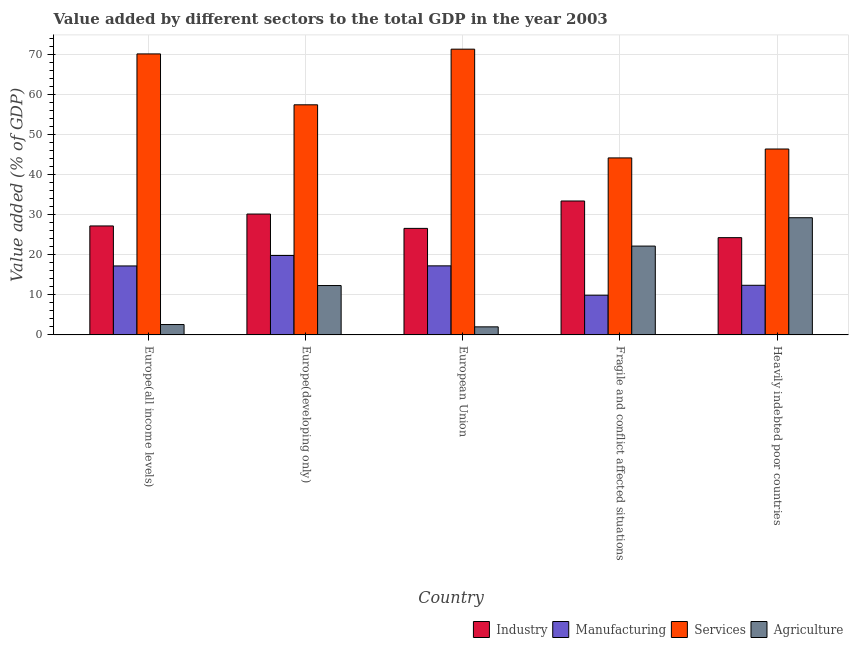How many groups of bars are there?
Make the answer very short. 5. Are the number of bars on each tick of the X-axis equal?
Offer a very short reply. Yes. What is the label of the 2nd group of bars from the left?
Keep it short and to the point. Europe(developing only). What is the value added by industrial sector in European Union?
Your answer should be very brief. 26.61. Across all countries, what is the maximum value added by manufacturing sector?
Your response must be concise. 19.84. Across all countries, what is the minimum value added by manufacturing sector?
Ensure brevity in your answer.  9.92. In which country was the value added by industrial sector maximum?
Your answer should be very brief. Fragile and conflict affected situations. What is the total value added by agricultural sector in the graph?
Your answer should be very brief. 68.4. What is the difference between the value added by agricultural sector in Europe(developing only) and that in Fragile and conflict affected situations?
Ensure brevity in your answer.  -9.85. What is the difference between the value added by agricultural sector in European Union and the value added by industrial sector in Fragile and conflict affected situations?
Provide a succinct answer. -31.44. What is the average value added by industrial sector per country?
Keep it short and to the point. 28.35. What is the difference between the value added by manufacturing sector and value added by services sector in Heavily indebted poor countries?
Offer a very short reply. -34.04. In how many countries, is the value added by agricultural sector greater than 6 %?
Offer a very short reply. 3. What is the ratio of the value added by industrial sector in European Union to that in Fragile and conflict affected situations?
Provide a succinct answer. 0.8. Is the value added by manufacturing sector in European Union less than that in Heavily indebted poor countries?
Offer a very short reply. No. What is the difference between the highest and the second highest value added by services sector?
Your response must be concise. 1.18. What is the difference between the highest and the lowest value added by agricultural sector?
Your answer should be very brief. 27.26. In how many countries, is the value added by industrial sector greater than the average value added by industrial sector taken over all countries?
Your response must be concise. 2. Is it the case that in every country, the sum of the value added by manufacturing sector and value added by services sector is greater than the sum of value added by agricultural sector and value added by industrial sector?
Your answer should be very brief. No. What does the 1st bar from the left in Heavily indebted poor countries represents?
Your answer should be very brief. Industry. What does the 2nd bar from the right in Heavily indebted poor countries represents?
Offer a terse response. Services. What is the difference between two consecutive major ticks on the Y-axis?
Provide a short and direct response. 10. Are the values on the major ticks of Y-axis written in scientific E-notation?
Make the answer very short. No. Does the graph contain any zero values?
Keep it short and to the point. No. Does the graph contain grids?
Ensure brevity in your answer.  Yes. How are the legend labels stacked?
Keep it short and to the point. Horizontal. What is the title of the graph?
Your response must be concise. Value added by different sectors to the total GDP in the year 2003. Does "Regional development banks" appear as one of the legend labels in the graph?
Provide a succinct answer. No. What is the label or title of the Y-axis?
Keep it short and to the point. Value added (% of GDP). What is the Value added (% of GDP) in Industry in Europe(all income levels)?
Offer a very short reply. 27.22. What is the Value added (% of GDP) in Manufacturing in Europe(all income levels)?
Your answer should be compact. 17.23. What is the Value added (% of GDP) of Services in Europe(all income levels)?
Offer a very short reply. 70.19. What is the Value added (% of GDP) in Agriculture in Europe(all income levels)?
Your answer should be compact. 2.59. What is the Value added (% of GDP) in Industry in Europe(developing only)?
Offer a very short reply. 30.19. What is the Value added (% of GDP) in Manufacturing in Europe(developing only)?
Provide a short and direct response. 19.84. What is the Value added (% of GDP) of Services in Europe(developing only)?
Make the answer very short. 57.48. What is the Value added (% of GDP) in Agriculture in Europe(developing only)?
Provide a succinct answer. 12.33. What is the Value added (% of GDP) of Industry in European Union?
Offer a terse response. 26.61. What is the Value added (% of GDP) in Manufacturing in European Union?
Give a very brief answer. 17.25. What is the Value added (% of GDP) in Services in European Union?
Provide a short and direct response. 71.38. What is the Value added (% of GDP) in Agriculture in European Union?
Your response must be concise. 2.02. What is the Value added (% of GDP) in Industry in Fragile and conflict affected situations?
Offer a terse response. 33.45. What is the Value added (% of GDP) of Manufacturing in Fragile and conflict affected situations?
Provide a succinct answer. 9.92. What is the Value added (% of GDP) in Services in Fragile and conflict affected situations?
Your answer should be compact. 44.21. What is the Value added (% of GDP) of Agriculture in Fragile and conflict affected situations?
Provide a short and direct response. 22.19. What is the Value added (% of GDP) in Industry in Heavily indebted poor countries?
Give a very brief answer. 24.29. What is the Value added (% of GDP) in Manufacturing in Heavily indebted poor countries?
Your response must be concise. 12.39. What is the Value added (% of GDP) in Services in Heavily indebted poor countries?
Ensure brevity in your answer.  46.44. What is the Value added (% of GDP) of Agriculture in Heavily indebted poor countries?
Give a very brief answer. 29.27. Across all countries, what is the maximum Value added (% of GDP) in Industry?
Offer a terse response. 33.45. Across all countries, what is the maximum Value added (% of GDP) of Manufacturing?
Your response must be concise. 19.84. Across all countries, what is the maximum Value added (% of GDP) of Services?
Ensure brevity in your answer.  71.38. Across all countries, what is the maximum Value added (% of GDP) of Agriculture?
Ensure brevity in your answer.  29.27. Across all countries, what is the minimum Value added (% of GDP) of Industry?
Keep it short and to the point. 24.29. Across all countries, what is the minimum Value added (% of GDP) in Manufacturing?
Make the answer very short. 9.92. Across all countries, what is the minimum Value added (% of GDP) of Services?
Ensure brevity in your answer.  44.21. Across all countries, what is the minimum Value added (% of GDP) in Agriculture?
Offer a terse response. 2.02. What is the total Value added (% of GDP) of Industry in the graph?
Your response must be concise. 141.76. What is the total Value added (% of GDP) of Manufacturing in the graph?
Offer a terse response. 76.63. What is the total Value added (% of GDP) of Services in the graph?
Your answer should be very brief. 289.69. What is the total Value added (% of GDP) of Agriculture in the graph?
Your response must be concise. 68.4. What is the difference between the Value added (% of GDP) of Industry in Europe(all income levels) and that in Europe(developing only)?
Provide a succinct answer. -2.98. What is the difference between the Value added (% of GDP) in Manufacturing in Europe(all income levels) and that in Europe(developing only)?
Provide a short and direct response. -2.61. What is the difference between the Value added (% of GDP) of Services in Europe(all income levels) and that in Europe(developing only)?
Ensure brevity in your answer.  12.72. What is the difference between the Value added (% of GDP) of Agriculture in Europe(all income levels) and that in Europe(developing only)?
Provide a succinct answer. -9.74. What is the difference between the Value added (% of GDP) of Industry in Europe(all income levels) and that in European Union?
Your answer should be compact. 0.61. What is the difference between the Value added (% of GDP) of Manufacturing in Europe(all income levels) and that in European Union?
Offer a terse response. -0.02. What is the difference between the Value added (% of GDP) of Services in Europe(all income levels) and that in European Union?
Provide a short and direct response. -1.19. What is the difference between the Value added (% of GDP) in Agriculture in Europe(all income levels) and that in European Union?
Offer a very short reply. 0.58. What is the difference between the Value added (% of GDP) of Industry in Europe(all income levels) and that in Fragile and conflict affected situations?
Make the answer very short. -6.24. What is the difference between the Value added (% of GDP) of Manufacturing in Europe(all income levels) and that in Fragile and conflict affected situations?
Keep it short and to the point. 7.31. What is the difference between the Value added (% of GDP) in Services in Europe(all income levels) and that in Fragile and conflict affected situations?
Offer a terse response. 25.98. What is the difference between the Value added (% of GDP) in Agriculture in Europe(all income levels) and that in Fragile and conflict affected situations?
Your answer should be compact. -19.59. What is the difference between the Value added (% of GDP) of Industry in Europe(all income levels) and that in Heavily indebted poor countries?
Give a very brief answer. 2.92. What is the difference between the Value added (% of GDP) in Manufacturing in Europe(all income levels) and that in Heavily indebted poor countries?
Ensure brevity in your answer.  4.84. What is the difference between the Value added (% of GDP) in Services in Europe(all income levels) and that in Heavily indebted poor countries?
Provide a short and direct response. 23.76. What is the difference between the Value added (% of GDP) in Agriculture in Europe(all income levels) and that in Heavily indebted poor countries?
Give a very brief answer. -26.68. What is the difference between the Value added (% of GDP) of Industry in Europe(developing only) and that in European Union?
Your answer should be compact. 3.58. What is the difference between the Value added (% of GDP) in Manufacturing in Europe(developing only) and that in European Union?
Offer a terse response. 2.59. What is the difference between the Value added (% of GDP) in Services in Europe(developing only) and that in European Union?
Your answer should be compact. -13.9. What is the difference between the Value added (% of GDP) of Agriculture in Europe(developing only) and that in European Union?
Provide a short and direct response. 10.32. What is the difference between the Value added (% of GDP) in Industry in Europe(developing only) and that in Fragile and conflict affected situations?
Your answer should be very brief. -3.26. What is the difference between the Value added (% of GDP) in Manufacturing in Europe(developing only) and that in Fragile and conflict affected situations?
Provide a succinct answer. 9.92. What is the difference between the Value added (% of GDP) in Services in Europe(developing only) and that in Fragile and conflict affected situations?
Your response must be concise. 13.26. What is the difference between the Value added (% of GDP) of Agriculture in Europe(developing only) and that in Fragile and conflict affected situations?
Ensure brevity in your answer.  -9.85. What is the difference between the Value added (% of GDP) in Industry in Europe(developing only) and that in Heavily indebted poor countries?
Offer a very short reply. 5.9. What is the difference between the Value added (% of GDP) of Manufacturing in Europe(developing only) and that in Heavily indebted poor countries?
Provide a short and direct response. 7.45. What is the difference between the Value added (% of GDP) of Services in Europe(developing only) and that in Heavily indebted poor countries?
Provide a short and direct response. 11.04. What is the difference between the Value added (% of GDP) in Agriculture in Europe(developing only) and that in Heavily indebted poor countries?
Give a very brief answer. -16.94. What is the difference between the Value added (% of GDP) of Industry in European Union and that in Fragile and conflict affected situations?
Ensure brevity in your answer.  -6.84. What is the difference between the Value added (% of GDP) of Manufacturing in European Union and that in Fragile and conflict affected situations?
Your response must be concise. 7.34. What is the difference between the Value added (% of GDP) of Services in European Union and that in Fragile and conflict affected situations?
Your response must be concise. 27.16. What is the difference between the Value added (% of GDP) of Agriculture in European Union and that in Fragile and conflict affected situations?
Your answer should be very brief. -20.17. What is the difference between the Value added (% of GDP) of Industry in European Union and that in Heavily indebted poor countries?
Make the answer very short. 2.32. What is the difference between the Value added (% of GDP) in Manufacturing in European Union and that in Heavily indebted poor countries?
Give a very brief answer. 4.86. What is the difference between the Value added (% of GDP) of Services in European Union and that in Heavily indebted poor countries?
Make the answer very short. 24.94. What is the difference between the Value added (% of GDP) in Agriculture in European Union and that in Heavily indebted poor countries?
Offer a terse response. -27.26. What is the difference between the Value added (% of GDP) of Industry in Fragile and conflict affected situations and that in Heavily indebted poor countries?
Your answer should be very brief. 9.16. What is the difference between the Value added (% of GDP) of Manufacturing in Fragile and conflict affected situations and that in Heavily indebted poor countries?
Keep it short and to the point. -2.48. What is the difference between the Value added (% of GDP) in Services in Fragile and conflict affected situations and that in Heavily indebted poor countries?
Provide a short and direct response. -2.22. What is the difference between the Value added (% of GDP) of Agriculture in Fragile and conflict affected situations and that in Heavily indebted poor countries?
Make the answer very short. -7.08. What is the difference between the Value added (% of GDP) of Industry in Europe(all income levels) and the Value added (% of GDP) of Manufacturing in Europe(developing only)?
Make the answer very short. 7.38. What is the difference between the Value added (% of GDP) of Industry in Europe(all income levels) and the Value added (% of GDP) of Services in Europe(developing only)?
Your answer should be compact. -30.26. What is the difference between the Value added (% of GDP) in Industry in Europe(all income levels) and the Value added (% of GDP) in Agriculture in Europe(developing only)?
Keep it short and to the point. 14.88. What is the difference between the Value added (% of GDP) in Manufacturing in Europe(all income levels) and the Value added (% of GDP) in Services in Europe(developing only)?
Offer a very short reply. -40.25. What is the difference between the Value added (% of GDP) of Manufacturing in Europe(all income levels) and the Value added (% of GDP) of Agriculture in Europe(developing only)?
Offer a terse response. 4.9. What is the difference between the Value added (% of GDP) of Services in Europe(all income levels) and the Value added (% of GDP) of Agriculture in Europe(developing only)?
Your answer should be compact. 57.86. What is the difference between the Value added (% of GDP) in Industry in Europe(all income levels) and the Value added (% of GDP) in Manufacturing in European Union?
Provide a succinct answer. 9.97. What is the difference between the Value added (% of GDP) of Industry in Europe(all income levels) and the Value added (% of GDP) of Services in European Union?
Offer a terse response. -44.16. What is the difference between the Value added (% of GDP) of Industry in Europe(all income levels) and the Value added (% of GDP) of Agriculture in European Union?
Give a very brief answer. 25.2. What is the difference between the Value added (% of GDP) in Manufacturing in Europe(all income levels) and the Value added (% of GDP) in Services in European Union?
Keep it short and to the point. -54.15. What is the difference between the Value added (% of GDP) in Manufacturing in Europe(all income levels) and the Value added (% of GDP) in Agriculture in European Union?
Keep it short and to the point. 15.21. What is the difference between the Value added (% of GDP) of Services in Europe(all income levels) and the Value added (% of GDP) of Agriculture in European Union?
Your answer should be compact. 68.18. What is the difference between the Value added (% of GDP) in Industry in Europe(all income levels) and the Value added (% of GDP) in Manufacturing in Fragile and conflict affected situations?
Provide a succinct answer. 17.3. What is the difference between the Value added (% of GDP) in Industry in Europe(all income levels) and the Value added (% of GDP) in Services in Fragile and conflict affected situations?
Make the answer very short. -17. What is the difference between the Value added (% of GDP) of Industry in Europe(all income levels) and the Value added (% of GDP) of Agriculture in Fragile and conflict affected situations?
Offer a very short reply. 5.03. What is the difference between the Value added (% of GDP) of Manufacturing in Europe(all income levels) and the Value added (% of GDP) of Services in Fragile and conflict affected situations?
Offer a terse response. -26.98. What is the difference between the Value added (% of GDP) of Manufacturing in Europe(all income levels) and the Value added (% of GDP) of Agriculture in Fragile and conflict affected situations?
Provide a short and direct response. -4.96. What is the difference between the Value added (% of GDP) of Services in Europe(all income levels) and the Value added (% of GDP) of Agriculture in Fragile and conflict affected situations?
Make the answer very short. 48. What is the difference between the Value added (% of GDP) in Industry in Europe(all income levels) and the Value added (% of GDP) in Manufacturing in Heavily indebted poor countries?
Your answer should be compact. 14.82. What is the difference between the Value added (% of GDP) in Industry in Europe(all income levels) and the Value added (% of GDP) in Services in Heavily indebted poor countries?
Your answer should be compact. -19.22. What is the difference between the Value added (% of GDP) of Industry in Europe(all income levels) and the Value added (% of GDP) of Agriculture in Heavily indebted poor countries?
Offer a very short reply. -2.05. What is the difference between the Value added (% of GDP) in Manufacturing in Europe(all income levels) and the Value added (% of GDP) in Services in Heavily indebted poor countries?
Your response must be concise. -29.21. What is the difference between the Value added (% of GDP) of Manufacturing in Europe(all income levels) and the Value added (% of GDP) of Agriculture in Heavily indebted poor countries?
Provide a short and direct response. -12.04. What is the difference between the Value added (% of GDP) in Services in Europe(all income levels) and the Value added (% of GDP) in Agriculture in Heavily indebted poor countries?
Your answer should be compact. 40.92. What is the difference between the Value added (% of GDP) of Industry in Europe(developing only) and the Value added (% of GDP) of Manufacturing in European Union?
Offer a very short reply. 12.94. What is the difference between the Value added (% of GDP) in Industry in Europe(developing only) and the Value added (% of GDP) in Services in European Union?
Provide a short and direct response. -41.18. What is the difference between the Value added (% of GDP) in Industry in Europe(developing only) and the Value added (% of GDP) in Agriculture in European Union?
Give a very brief answer. 28.18. What is the difference between the Value added (% of GDP) of Manufacturing in Europe(developing only) and the Value added (% of GDP) of Services in European Union?
Provide a short and direct response. -51.54. What is the difference between the Value added (% of GDP) of Manufacturing in Europe(developing only) and the Value added (% of GDP) of Agriculture in European Union?
Make the answer very short. 17.82. What is the difference between the Value added (% of GDP) of Services in Europe(developing only) and the Value added (% of GDP) of Agriculture in European Union?
Ensure brevity in your answer.  55.46. What is the difference between the Value added (% of GDP) in Industry in Europe(developing only) and the Value added (% of GDP) in Manufacturing in Fragile and conflict affected situations?
Ensure brevity in your answer.  20.28. What is the difference between the Value added (% of GDP) of Industry in Europe(developing only) and the Value added (% of GDP) of Services in Fragile and conflict affected situations?
Offer a very short reply. -14.02. What is the difference between the Value added (% of GDP) in Industry in Europe(developing only) and the Value added (% of GDP) in Agriculture in Fragile and conflict affected situations?
Ensure brevity in your answer.  8. What is the difference between the Value added (% of GDP) of Manufacturing in Europe(developing only) and the Value added (% of GDP) of Services in Fragile and conflict affected situations?
Your answer should be compact. -24.37. What is the difference between the Value added (% of GDP) in Manufacturing in Europe(developing only) and the Value added (% of GDP) in Agriculture in Fragile and conflict affected situations?
Provide a succinct answer. -2.35. What is the difference between the Value added (% of GDP) of Services in Europe(developing only) and the Value added (% of GDP) of Agriculture in Fragile and conflict affected situations?
Give a very brief answer. 35.29. What is the difference between the Value added (% of GDP) in Industry in Europe(developing only) and the Value added (% of GDP) in Manufacturing in Heavily indebted poor countries?
Keep it short and to the point. 17.8. What is the difference between the Value added (% of GDP) of Industry in Europe(developing only) and the Value added (% of GDP) of Services in Heavily indebted poor countries?
Your answer should be very brief. -16.24. What is the difference between the Value added (% of GDP) of Industry in Europe(developing only) and the Value added (% of GDP) of Agriculture in Heavily indebted poor countries?
Provide a succinct answer. 0.92. What is the difference between the Value added (% of GDP) in Manufacturing in Europe(developing only) and the Value added (% of GDP) in Services in Heavily indebted poor countries?
Your response must be concise. -26.6. What is the difference between the Value added (% of GDP) in Manufacturing in Europe(developing only) and the Value added (% of GDP) in Agriculture in Heavily indebted poor countries?
Keep it short and to the point. -9.43. What is the difference between the Value added (% of GDP) of Services in Europe(developing only) and the Value added (% of GDP) of Agriculture in Heavily indebted poor countries?
Ensure brevity in your answer.  28.2. What is the difference between the Value added (% of GDP) of Industry in European Union and the Value added (% of GDP) of Manufacturing in Fragile and conflict affected situations?
Your response must be concise. 16.69. What is the difference between the Value added (% of GDP) of Industry in European Union and the Value added (% of GDP) of Services in Fragile and conflict affected situations?
Offer a terse response. -17.6. What is the difference between the Value added (% of GDP) in Industry in European Union and the Value added (% of GDP) in Agriculture in Fragile and conflict affected situations?
Give a very brief answer. 4.42. What is the difference between the Value added (% of GDP) in Manufacturing in European Union and the Value added (% of GDP) in Services in Fragile and conflict affected situations?
Give a very brief answer. -26.96. What is the difference between the Value added (% of GDP) of Manufacturing in European Union and the Value added (% of GDP) of Agriculture in Fragile and conflict affected situations?
Provide a short and direct response. -4.94. What is the difference between the Value added (% of GDP) in Services in European Union and the Value added (% of GDP) in Agriculture in Fragile and conflict affected situations?
Your answer should be very brief. 49.19. What is the difference between the Value added (% of GDP) in Industry in European Union and the Value added (% of GDP) in Manufacturing in Heavily indebted poor countries?
Your answer should be very brief. 14.22. What is the difference between the Value added (% of GDP) of Industry in European Union and the Value added (% of GDP) of Services in Heavily indebted poor countries?
Make the answer very short. -19.83. What is the difference between the Value added (% of GDP) in Industry in European Union and the Value added (% of GDP) in Agriculture in Heavily indebted poor countries?
Your answer should be compact. -2.66. What is the difference between the Value added (% of GDP) of Manufacturing in European Union and the Value added (% of GDP) of Services in Heavily indebted poor countries?
Your answer should be compact. -29.18. What is the difference between the Value added (% of GDP) of Manufacturing in European Union and the Value added (% of GDP) of Agriculture in Heavily indebted poor countries?
Give a very brief answer. -12.02. What is the difference between the Value added (% of GDP) in Services in European Union and the Value added (% of GDP) in Agriculture in Heavily indebted poor countries?
Keep it short and to the point. 42.11. What is the difference between the Value added (% of GDP) in Industry in Fragile and conflict affected situations and the Value added (% of GDP) in Manufacturing in Heavily indebted poor countries?
Make the answer very short. 21.06. What is the difference between the Value added (% of GDP) of Industry in Fragile and conflict affected situations and the Value added (% of GDP) of Services in Heavily indebted poor countries?
Your answer should be very brief. -12.98. What is the difference between the Value added (% of GDP) in Industry in Fragile and conflict affected situations and the Value added (% of GDP) in Agriculture in Heavily indebted poor countries?
Offer a terse response. 4.18. What is the difference between the Value added (% of GDP) of Manufacturing in Fragile and conflict affected situations and the Value added (% of GDP) of Services in Heavily indebted poor countries?
Make the answer very short. -36.52. What is the difference between the Value added (% of GDP) of Manufacturing in Fragile and conflict affected situations and the Value added (% of GDP) of Agriculture in Heavily indebted poor countries?
Ensure brevity in your answer.  -19.36. What is the difference between the Value added (% of GDP) of Services in Fragile and conflict affected situations and the Value added (% of GDP) of Agriculture in Heavily indebted poor countries?
Offer a terse response. 14.94. What is the average Value added (% of GDP) in Industry per country?
Make the answer very short. 28.35. What is the average Value added (% of GDP) in Manufacturing per country?
Keep it short and to the point. 15.33. What is the average Value added (% of GDP) in Services per country?
Ensure brevity in your answer.  57.94. What is the average Value added (% of GDP) in Agriculture per country?
Your response must be concise. 13.68. What is the difference between the Value added (% of GDP) in Industry and Value added (% of GDP) in Manufacturing in Europe(all income levels)?
Give a very brief answer. 9.99. What is the difference between the Value added (% of GDP) in Industry and Value added (% of GDP) in Services in Europe(all income levels)?
Your answer should be very brief. -42.97. What is the difference between the Value added (% of GDP) in Industry and Value added (% of GDP) in Agriculture in Europe(all income levels)?
Your response must be concise. 24.62. What is the difference between the Value added (% of GDP) in Manufacturing and Value added (% of GDP) in Services in Europe(all income levels)?
Offer a terse response. -52.96. What is the difference between the Value added (% of GDP) of Manufacturing and Value added (% of GDP) of Agriculture in Europe(all income levels)?
Provide a short and direct response. 14.64. What is the difference between the Value added (% of GDP) of Services and Value added (% of GDP) of Agriculture in Europe(all income levels)?
Offer a very short reply. 67.6. What is the difference between the Value added (% of GDP) in Industry and Value added (% of GDP) in Manufacturing in Europe(developing only)?
Provide a succinct answer. 10.35. What is the difference between the Value added (% of GDP) of Industry and Value added (% of GDP) of Services in Europe(developing only)?
Provide a succinct answer. -27.28. What is the difference between the Value added (% of GDP) of Industry and Value added (% of GDP) of Agriculture in Europe(developing only)?
Offer a very short reply. 17.86. What is the difference between the Value added (% of GDP) in Manufacturing and Value added (% of GDP) in Services in Europe(developing only)?
Provide a succinct answer. -37.64. What is the difference between the Value added (% of GDP) in Manufacturing and Value added (% of GDP) in Agriculture in Europe(developing only)?
Ensure brevity in your answer.  7.51. What is the difference between the Value added (% of GDP) in Services and Value added (% of GDP) in Agriculture in Europe(developing only)?
Keep it short and to the point. 45.14. What is the difference between the Value added (% of GDP) in Industry and Value added (% of GDP) in Manufacturing in European Union?
Ensure brevity in your answer.  9.36. What is the difference between the Value added (% of GDP) in Industry and Value added (% of GDP) in Services in European Union?
Provide a succinct answer. -44.77. What is the difference between the Value added (% of GDP) in Industry and Value added (% of GDP) in Agriculture in European Union?
Your answer should be compact. 24.59. What is the difference between the Value added (% of GDP) of Manufacturing and Value added (% of GDP) of Services in European Union?
Give a very brief answer. -54.12. What is the difference between the Value added (% of GDP) in Manufacturing and Value added (% of GDP) in Agriculture in European Union?
Ensure brevity in your answer.  15.24. What is the difference between the Value added (% of GDP) of Services and Value added (% of GDP) of Agriculture in European Union?
Your answer should be very brief. 69.36. What is the difference between the Value added (% of GDP) of Industry and Value added (% of GDP) of Manufacturing in Fragile and conflict affected situations?
Your answer should be very brief. 23.54. What is the difference between the Value added (% of GDP) of Industry and Value added (% of GDP) of Services in Fragile and conflict affected situations?
Provide a succinct answer. -10.76. What is the difference between the Value added (% of GDP) of Industry and Value added (% of GDP) of Agriculture in Fragile and conflict affected situations?
Ensure brevity in your answer.  11.26. What is the difference between the Value added (% of GDP) in Manufacturing and Value added (% of GDP) in Services in Fragile and conflict affected situations?
Your response must be concise. -34.3. What is the difference between the Value added (% of GDP) in Manufacturing and Value added (% of GDP) in Agriculture in Fragile and conflict affected situations?
Provide a succinct answer. -12.27. What is the difference between the Value added (% of GDP) of Services and Value added (% of GDP) of Agriculture in Fragile and conflict affected situations?
Keep it short and to the point. 22.02. What is the difference between the Value added (% of GDP) in Industry and Value added (% of GDP) in Manufacturing in Heavily indebted poor countries?
Your answer should be very brief. 11.9. What is the difference between the Value added (% of GDP) of Industry and Value added (% of GDP) of Services in Heavily indebted poor countries?
Keep it short and to the point. -22.14. What is the difference between the Value added (% of GDP) of Industry and Value added (% of GDP) of Agriculture in Heavily indebted poor countries?
Offer a terse response. -4.98. What is the difference between the Value added (% of GDP) of Manufacturing and Value added (% of GDP) of Services in Heavily indebted poor countries?
Provide a succinct answer. -34.04. What is the difference between the Value added (% of GDP) in Manufacturing and Value added (% of GDP) in Agriculture in Heavily indebted poor countries?
Ensure brevity in your answer.  -16.88. What is the difference between the Value added (% of GDP) in Services and Value added (% of GDP) in Agriculture in Heavily indebted poor countries?
Your response must be concise. 17.16. What is the ratio of the Value added (% of GDP) of Industry in Europe(all income levels) to that in Europe(developing only)?
Your response must be concise. 0.9. What is the ratio of the Value added (% of GDP) in Manufacturing in Europe(all income levels) to that in Europe(developing only)?
Offer a very short reply. 0.87. What is the ratio of the Value added (% of GDP) in Services in Europe(all income levels) to that in Europe(developing only)?
Your answer should be very brief. 1.22. What is the ratio of the Value added (% of GDP) in Agriculture in Europe(all income levels) to that in Europe(developing only)?
Your answer should be compact. 0.21. What is the ratio of the Value added (% of GDP) in Industry in Europe(all income levels) to that in European Union?
Offer a very short reply. 1.02. What is the ratio of the Value added (% of GDP) of Services in Europe(all income levels) to that in European Union?
Keep it short and to the point. 0.98. What is the ratio of the Value added (% of GDP) in Agriculture in Europe(all income levels) to that in European Union?
Your answer should be compact. 1.29. What is the ratio of the Value added (% of GDP) of Industry in Europe(all income levels) to that in Fragile and conflict affected situations?
Give a very brief answer. 0.81. What is the ratio of the Value added (% of GDP) of Manufacturing in Europe(all income levels) to that in Fragile and conflict affected situations?
Your answer should be compact. 1.74. What is the ratio of the Value added (% of GDP) in Services in Europe(all income levels) to that in Fragile and conflict affected situations?
Make the answer very short. 1.59. What is the ratio of the Value added (% of GDP) in Agriculture in Europe(all income levels) to that in Fragile and conflict affected situations?
Offer a very short reply. 0.12. What is the ratio of the Value added (% of GDP) of Industry in Europe(all income levels) to that in Heavily indebted poor countries?
Make the answer very short. 1.12. What is the ratio of the Value added (% of GDP) of Manufacturing in Europe(all income levels) to that in Heavily indebted poor countries?
Your answer should be very brief. 1.39. What is the ratio of the Value added (% of GDP) in Services in Europe(all income levels) to that in Heavily indebted poor countries?
Ensure brevity in your answer.  1.51. What is the ratio of the Value added (% of GDP) in Agriculture in Europe(all income levels) to that in Heavily indebted poor countries?
Your response must be concise. 0.09. What is the ratio of the Value added (% of GDP) in Industry in Europe(developing only) to that in European Union?
Provide a succinct answer. 1.13. What is the ratio of the Value added (% of GDP) of Manufacturing in Europe(developing only) to that in European Union?
Ensure brevity in your answer.  1.15. What is the ratio of the Value added (% of GDP) of Services in Europe(developing only) to that in European Union?
Offer a terse response. 0.81. What is the ratio of the Value added (% of GDP) in Agriculture in Europe(developing only) to that in European Union?
Keep it short and to the point. 6.12. What is the ratio of the Value added (% of GDP) of Industry in Europe(developing only) to that in Fragile and conflict affected situations?
Give a very brief answer. 0.9. What is the ratio of the Value added (% of GDP) of Manufacturing in Europe(developing only) to that in Fragile and conflict affected situations?
Provide a short and direct response. 2. What is the ratio of the Value added (% of GDP) in Agriculture in Europe(developing only) to that in Fragile and conflict affected situations?
Your answer should be compact. 0.56. What is the ratio of the Value added (% of GDP) in Industry in Europe(developing only) to that in Heavily indebted poor countries?
Your answer should be compact. 1.24. What is the ratio of the Value added (% of GDP) in Manufacturing in Europe(developing only) to that in Heavily indebted poor countries?
Keep it short and to the point. 1.6. What is the ratio of the Value added (% of GDP) in Services in Europe(developing only) to that in Heavily indebted poor countries?
Provide a short and direct response. 1.24. What is the ratio of the Value added (% of GDP) in Agriculture in Europe(developing only) to that in Heavily indebted poor countries?
Ensure brevity in your answer.  0.42. What is the ratio of the Value added (% of GDP) of Industry in European Union to that in Fragile and conflict affected situations?
Your response must be concise. 0.8. What is the ratio of the Value added (% of GDP) in Manufacturing in European Union to that in Fragile and conflict affected situations?
Provide a succinct answer. 1.74. What is the ratio of the Value added (% of GDP) in Services in European Union to that in Fragile and conflict affected situations?
Offer a very short reply. 1.61. What is the ratio of the Value added (% of GDP) of Agriculture in European Union to that in Fragile and conflict affected situations?
Ensure brevity in your answer.  0.09. What is the ratio of the Value added (% of GDP) of Industry in European Union to that in Heavily indebted poor countries?
Your response must be concise. 1.1. What is the ratio of the Value added (% of GDP) in Manufacturing in European Union to that in Heavily indebted poor countries?
Offer a very short reply. 1.39. What is the ratio of the Value added (% of GDP) of Services in European Union to that in Heavily indebted poor countries?
Provide a short and direct response. 1.54. What is the ratio of the Value added (% of GDP) in Agriculture in European Union to that in Heavily indebted poor countries?
Give a very brief answer. 0.07. What is the ratio of the Value added (% of GDP) of Industry in Fragile and conflict affected situations to that in Heavily indebted poor countries?
Give a very brief answer. 1.38. What is the ratio of the Value added (% of GDP) of Manufacturing in Fragile and conflict affected situations to that in Heavily indebted poor countries?
Offer a very short reply. 0.8. What is the ratio of the Value added (% of GDP) in Services in Fragile and conflict affected situations to that in Heavily indebted poor countries?
Offer a very short reply. 0.95. What is the ratio of the Value added (% of GDP) of Agriculture in Fragile and conflict affected situations to that in Heavily indebted poor countries?
Provide a succinct answer. 0.76. What is the difference between the highest and the second highest Value added (% of GDP) in Industry?
Make the answer very short. 3.26. What is the difference between the highest and the second highest Value added (% of GDP) in Manufacturing?
Your answer should be very brief. 2.59. What is the difference between the highest and the second highest Value added (% of GDP) of Services?
Offer a terse response. 1.19. What is the difference between the highest and the second highest Value added (% of GDP) in Agriculture?
Provide a short and direct response. 7.08. What is the difference between the highest and the lowest Value added (% of GDP) of Industry?
Ensure brevity in your answer.  9.16. What is the difference between the highest and the lowest Value added (% of GDP) in Manufacturing?
Your response must be concise. 9.92. What is the difference between the highest and the lowest Value added (% of GDP) in Services?
Make the answer very short. 27.16. What is the difference between the highest and the lowest Value added (% of GDP) of Agriculture?
Your answer should be compact. 27.26. 